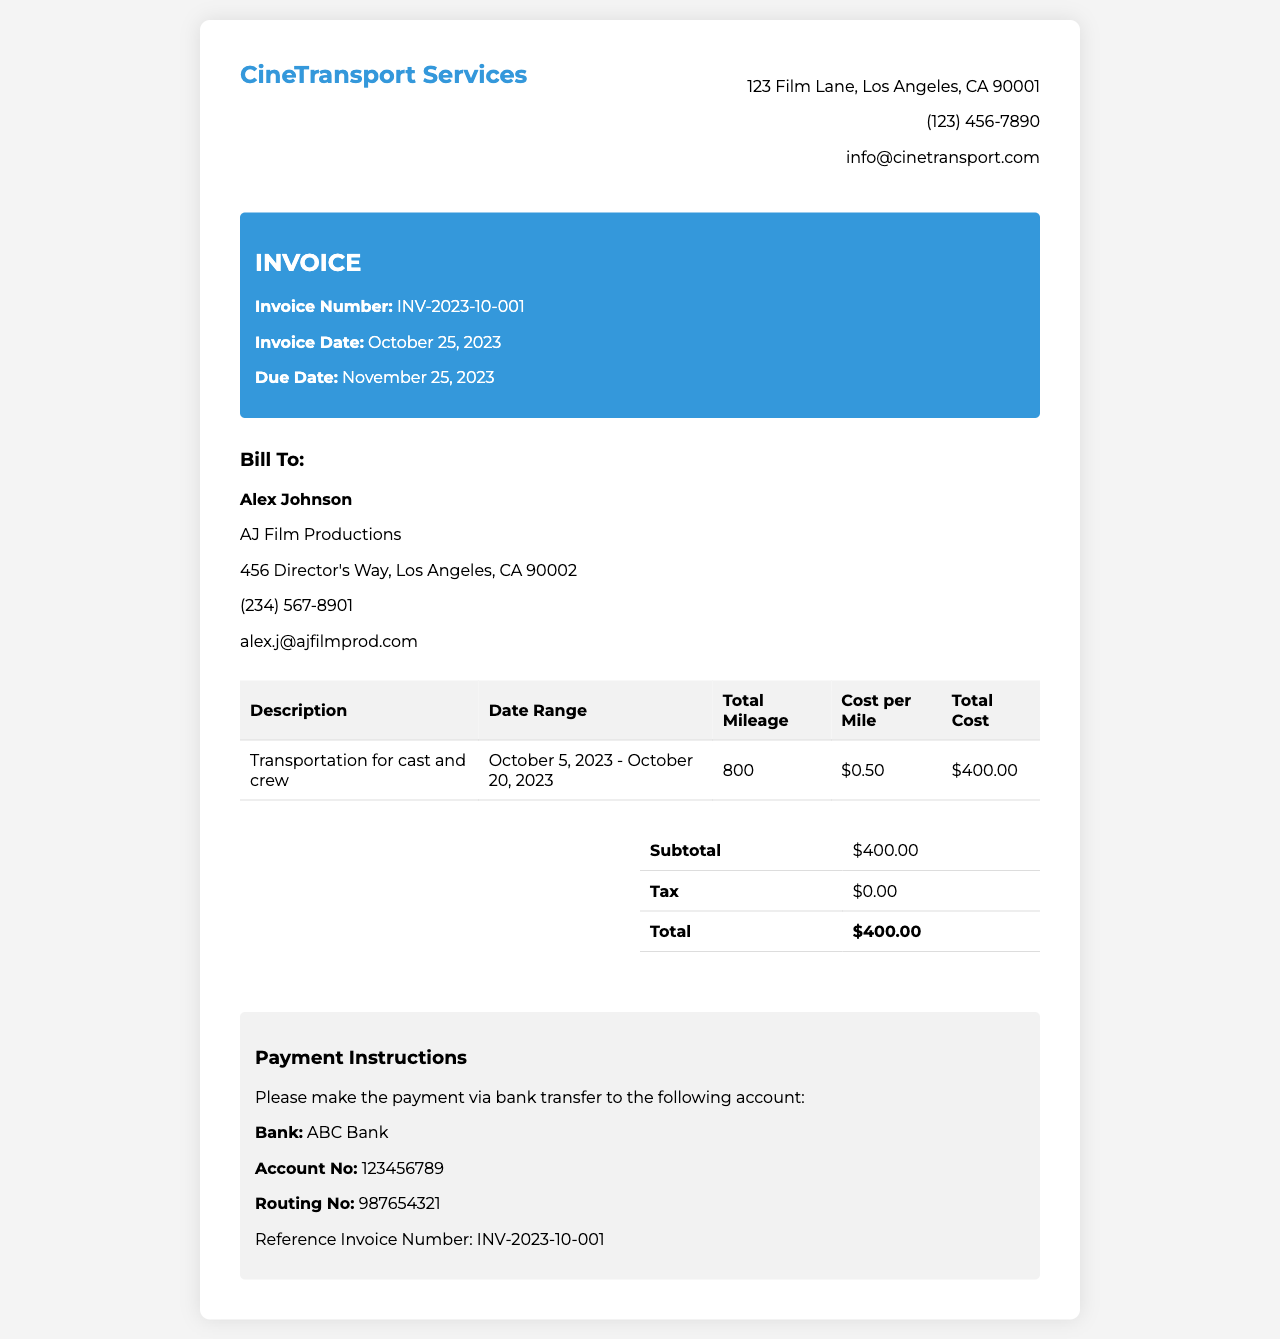what is the invoice number? The invoice number is listed in the invoice details section.
Answer: INV-2023-10-001 what is the total mileage for the transportation services? The total mileage can be found in the table under "Total Mileage."
Answer: 800 what is the cost per mile? The cost per mile is specified in the table.
Answer: $0.50 what is the total cost for transportation services? The total cost is the last entry in the summary table.
Answer: $400.00 who is the billed party? The billed party's name is located in the "Bill To" section.
Answer: Alex Johnson what is the payment due date? The due date is mentioned in the invoice details section.
Answer: November 25, 2023 what are the payment instructions for the invoice? The payment instructions are outlined in the payment instructions section.
Answer: Bank transfer to ABC Bank how long was the production period covered by this invoice? The production period is indicated in the description of services.
Answer: October 5, 2023 - October 20, 2023 is there any tax included in the total cost? The tax section in the summary table shows whether tax is included.
Answer: $0.00 